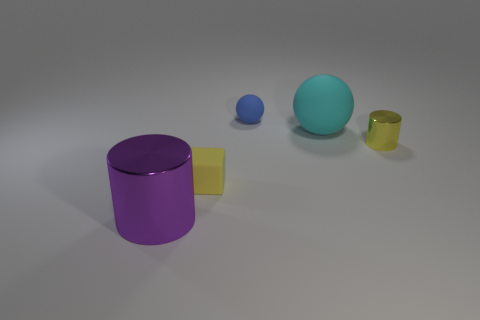Subtract all cyan spheres. Subtract all blue cylinders. How many spheres are left? 1 Add 2 small metal spheres. How many objects exist? 7 Subtract all cylinders. How many objects are left? 3 Add 3 shiny things. How many shiny things exist? 5 Subtract 0 cyan cylinders. How many objects are left? 5 Subtract all tiny purple rubber cylinders. Subtract all tiny blocks. How many objects are left? 4 Add 3 purple cylinders. How many purple cylinders are left? 4 